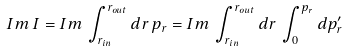Convert formula to latex. <formula><loc_0><loc_0><loc_500><loc_500>I m \, I = I m \, \int _ { r _ { i n } } ^ { r _ { o u t } } d r \, p _ { r } = I m \, \int _ { r _ { i n } } ^ { r _ { o u t } } d r \, \int _ { 0 } ^ { p _ { r } } d p ^ { \prime } _ { r }</formula> 